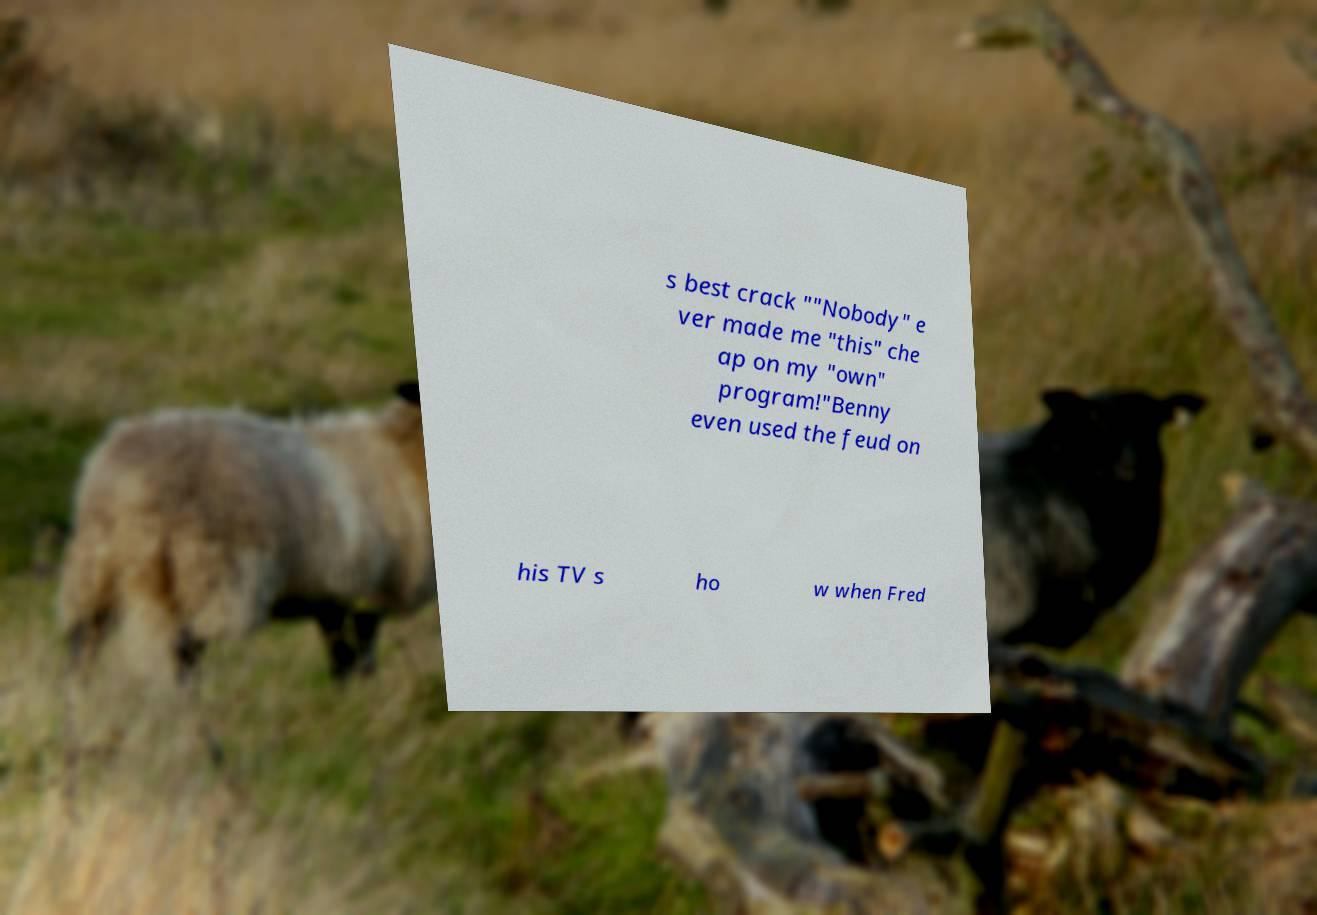What messages or text are displayed in this image? I need them in a readable, typed format. s best crack ""Nobody" e ver made me "this" che ap on my "own" program!"Benny even used the feud on his TV s ho w when Fred 